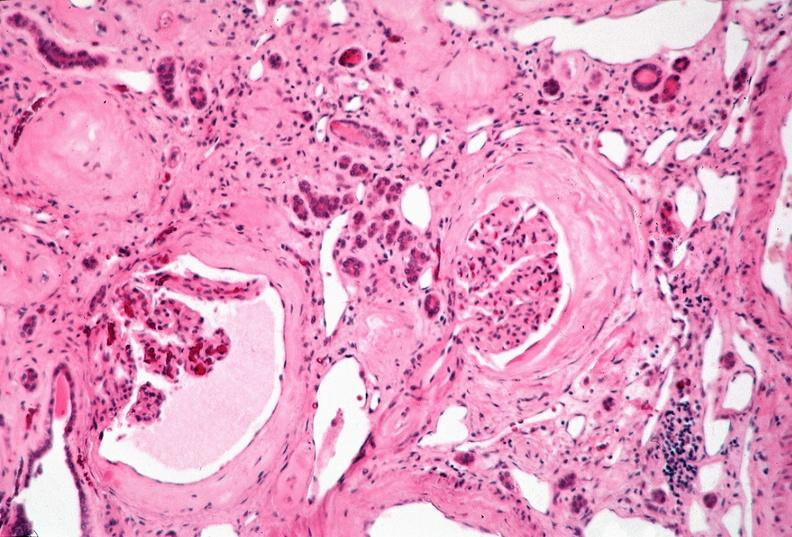what does this image show?
Answer the question using a single word or phrase. Kidney 